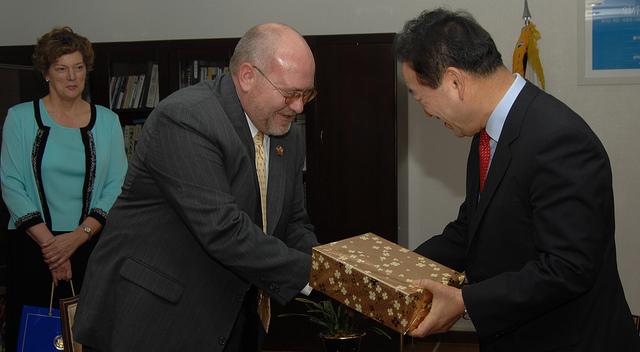What item is the man touching?
Give a very brief answer. Box. What is this guy doing?
Keep it brief. Shaking hands. What is the man holding?
Answer briefly. Gift. What color is the box?
Give a very brief answer. Brown. How many teddy bears are in the image?
Short answer required. 0. Is anyone else in the photo looking at the smiling couple?
Write a very short answer. Yes. What are the people holding?
Answer briefly. Box. How many people have beards?
Give a very brief answer. 1. Are both men bald?
Answer briefly. No. Are there surfboards?
Keep it brief. No. Is it likely the woman is holding the bag the box arrived in?
Write a very short answer. Yes. 